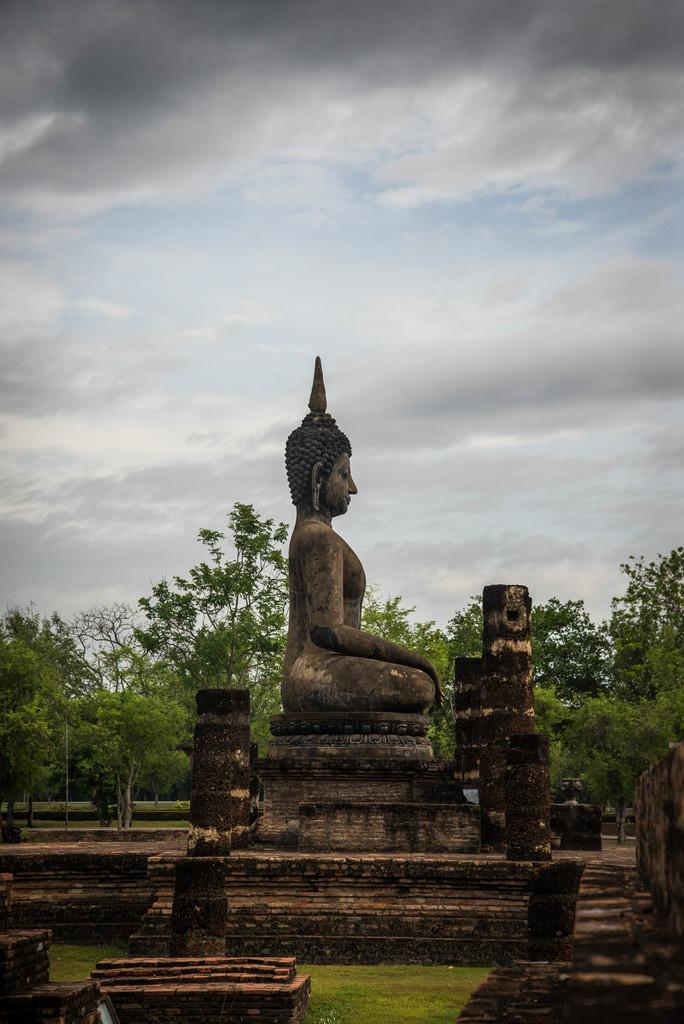What is the main subject of the image? There is a statue at the center of the image. What can be seen in the background of the image? There are trees and the sky visible in the background of the image. What type of chain is being used to protest against the statue in the image? There is no protest or chain present in the image; it only features a statue with trees and the sky in the background. 